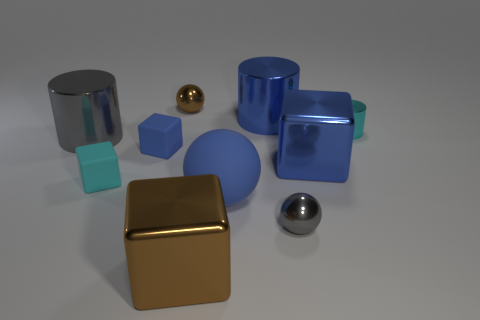Are there any gray objects of the same size as the cyan cylinder?
Your answer should be very brief. Yes. Is the shape of the large brown shiny object the same as the matte object that is behind the tiny cyan cube?
Keep it short and to the point. Yes. There is a large block that is right of the big shiny cylinder that is behind the large gray thing; is there a gray metal cylinder that is in front of it?
Your response must be concise. No. The blue ball has what size?
Offer a terse response. Large. How many other objects are there of the same color as the small metal cylinder?
Your answer should be very brief. 1. There is a small matte object that is in front of the big blue shiny block; does it have the same shape as the large gray shiny object?
Offer a very short reply. No. There is a big thing that is the same shape as the small brown thing; what is its color?
Give a very brief answer. Blue. What size is the blue rubber thing that is the same shape as the tiny gray metal object?
Ensure brevity in your answer.  Large. There is a tiny object that is both in front of the blue metallic block and to the left of the small brown object; what material is it made of?
Ensure brevity in your answer.  Rubber. Do the matte thing behind the cyan cube and the big rubber ball have the same color?
Make the answer very short. Yes. 